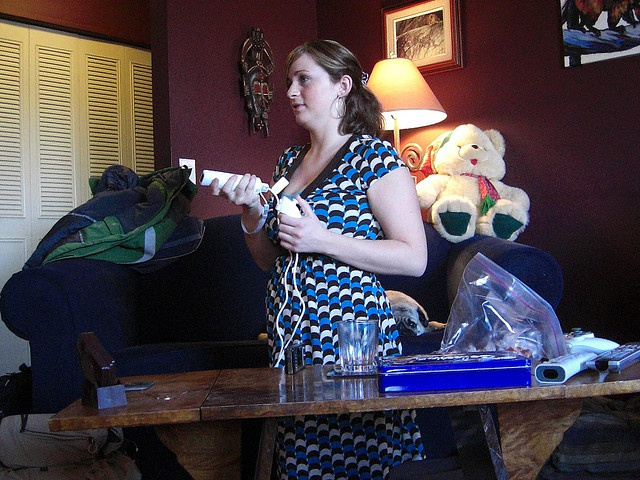Describe the objects in this image and their specific colors. I can see people in maroon, black, lavender, darkgray, and gray tones, dining table in maroon, black, and gray tones, couch in maroon, black, and gray tones, backpack in maroon, black, teal, navy, and darkgreen tones, and teddy bear in maroon, beige, tan, darkgray, and navy tones in this image. 